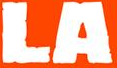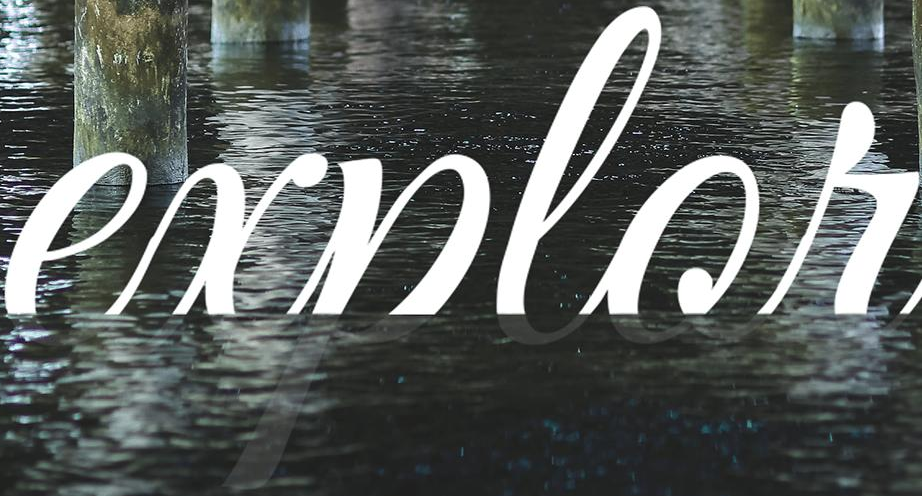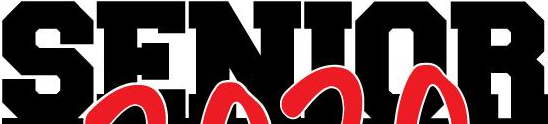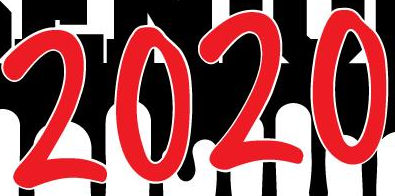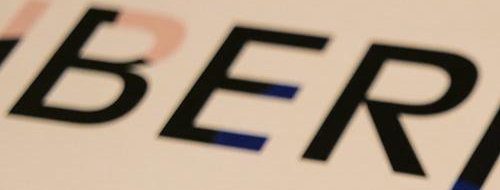What words are shown in these images in order, separated by a semicolon? LA; explor; SENIOR; 2020; BER 